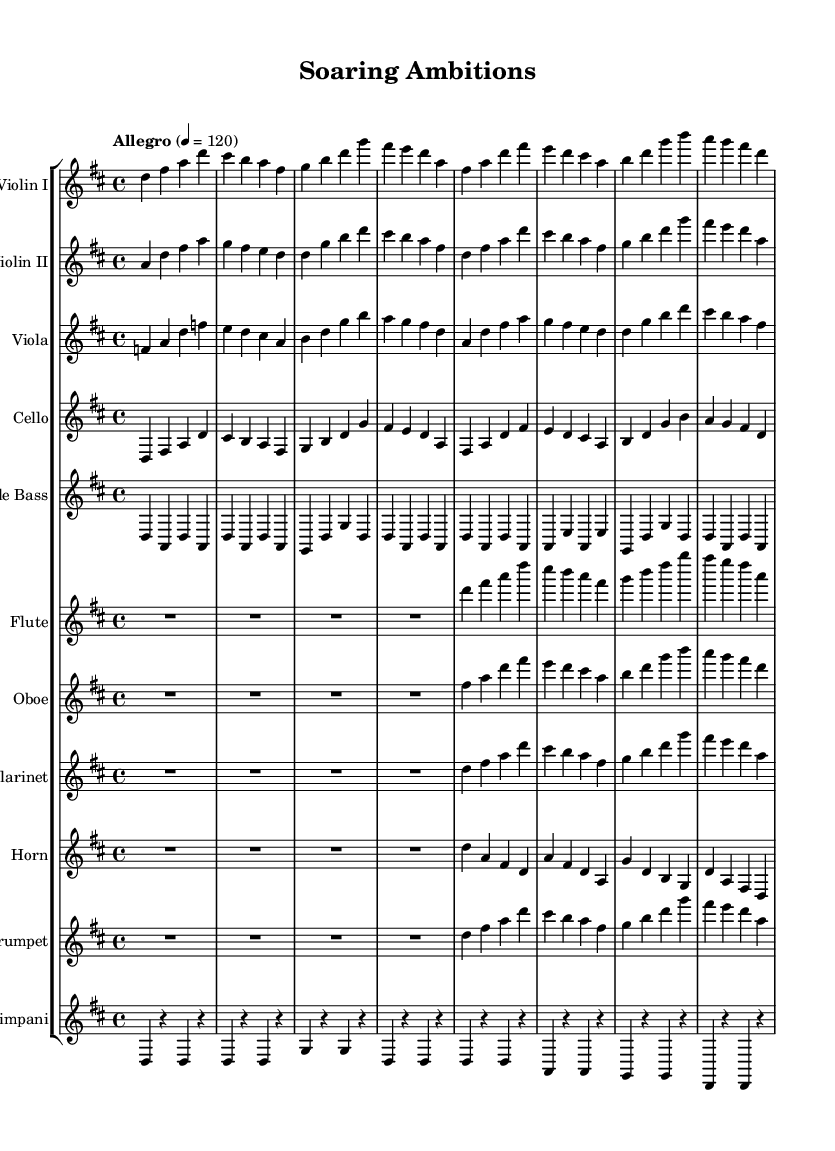What is the key signature of this music? The key signature is D major, which has two sharps (F# and C#). This can be identified by looking at the key signature shown at the beginning of the staff, which includes two sharps.
Answer: D major What is the time signature of this music? The time signature is indicated as 4/4 shown at the beginning of the score, which means there are four beats per measure and a quarter note receives one beat.
Answer: 4/4 What is the tempo marking for this piece? The tempo marking is "Allegro", which indicates a fast and lively pace. This is indicated above the staff at the beginning of the piece.
Answer: Allegro How many different instruments are included in this orchestration? There are ten different instruments listed in the score. This includes strings, woodwinds, and brass as indicated by each new staff for the respective instruments.
Answer: Ten Which instrument plays the melody mostly? The first violin tends to carry the melody as it often plays higher and more prominent notes compared to the other instruments, which typically support or harmonize.
Answer: Violin I What is the role of the timpani in this composition? The timpani usually provides rhythmic foundation and dynamic contrast in orchestral pieces. In this score, the timpani plays a supporting role with repeated notes and rests that complement the other instruments.
Answer: Rhythmic foundation What is the texture of the music in this composition? The texture is homophonic, meaning there is a clear melody in the violins supported by harmony from other instruments, creating a unified musical line. The voices largely move together harmonically.
Answer: Homophonic 